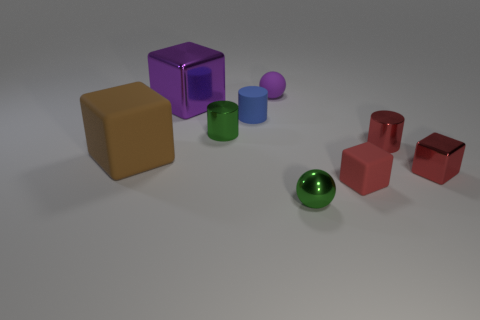What is the shape of the large object that is the same color as the small matte ball?
Give a very brief answer. Cube. Is there anything else that is the same color as the matte cylinder?
Your answer should be very brief. No. What number of rubber objects are either spheres or big blue cylinders?
Your response must be concise. 1. Does the tiny rubber sphere have the same color as the big metallic thing?
Ensure brevity in your answer.  Yes. Are there more big cubes that are in front of the large metallic object than yellow rubber cubes?
Keep it short and to the point. Yes. What number of other objects are the same material as the tiny purple ball?
Offer a terse response. 3. How many large objects are rubber things or purple balls?
Your answer should be compact. 1. Is the green cylinder made of the same material as the tiny purple ball?
Provide a short and direct response. No. There is a tiny red metallic thing that is behind the large brown cube; how many tiny green metallic spheres are on the right side of it?
Offer a terse response. 0. Are there any small red objects that have the same shape as the large brown object?
Provide a short and direct response. Yes. 